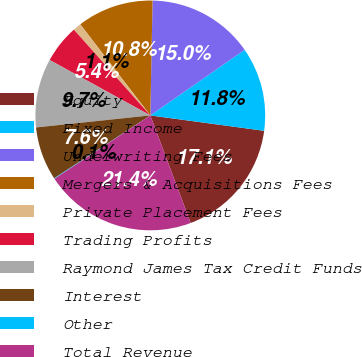<chart> <loc_0><loc_0><loc_500><loc_500><pie_chart><fcel>Equity<fcel>Fixed Income<fcel>Underwriting Fees<fcel>Mergers & Acquisitions Fees<fcel>Private Placement Fees<fcel>Trading Profits<fcel>Raymond James Tax Credit Funds<fcel>Interest<fcel>Other<fcel>Total Revenue<nl><fcel>17.15%<fcel>11.81%<fcel>15.01%<fcel>10.75%<fcel>1.15%<fcel>5.41%<fcel>9.68%<fcel>7.55%<fcel>0.08%<fcel>21.41%<nl></chart> 